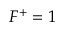Convert formula to latex. <formula><loc_0><loc_0><loc_500><loc_500>F ^ { + } = 1</formula> 